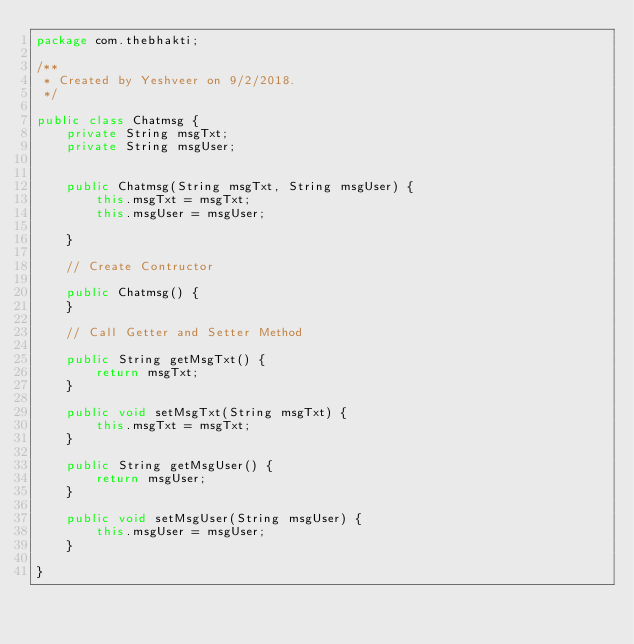Convert code to text. <code><loc_0><loc_0><loc_500><loc_500><_Java_>package com.thebhakti;

/**
 * Created by Yeshveer on 9/2/2018.
 */

public class Chatmsg {
    private String msgTxt;
    private String msgUser;


    public Chatmsg(String msgTxt, String msgUser) {
        this.msgTxt = msgTxt;
        this.msgUser = msgUser;

    }

    // Create Contructor

    public Chatmsg() {
    }

    // Call Getter and Setter Method

    public String getMsgTxt() {
        return msgTxt;
    }

    public void setMsgTxt(String msgTxt) {
        this.msgTxt = msgTxt;
    }

    public String getMsgUser() {
        return msgUser;
    }

    public void setMsgUser(String msgUser) {
        this.msgUser = msgUser;
    }

}
</code> 